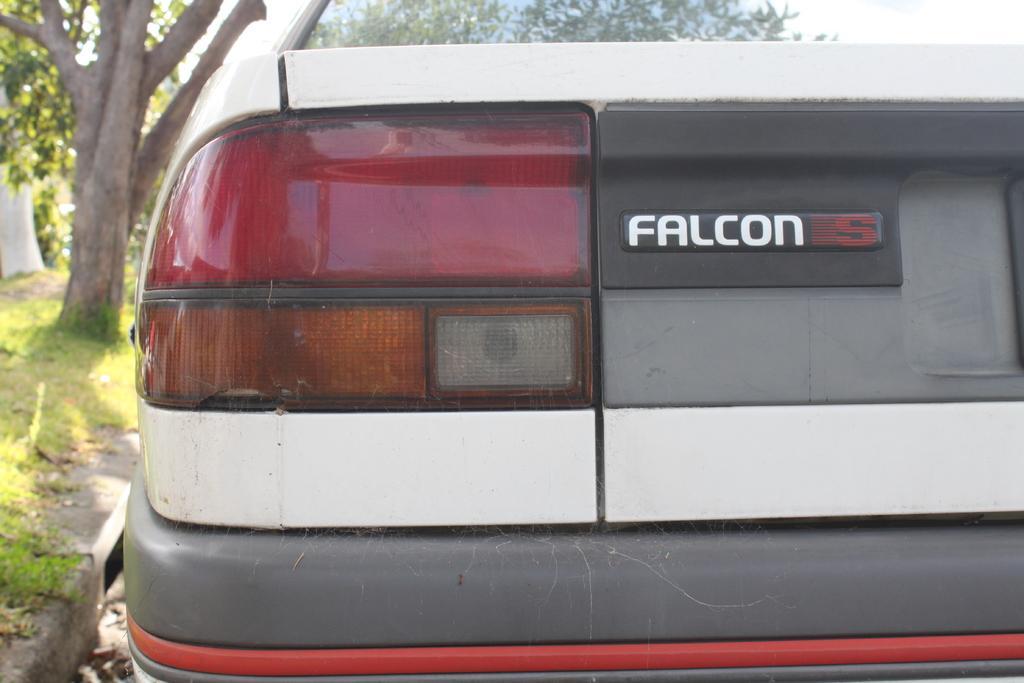Can you describe this image briefly? In this image I can see a car from the back side I can see car lights and some text on the car. On the left side of the image I can see a tree and grass.  